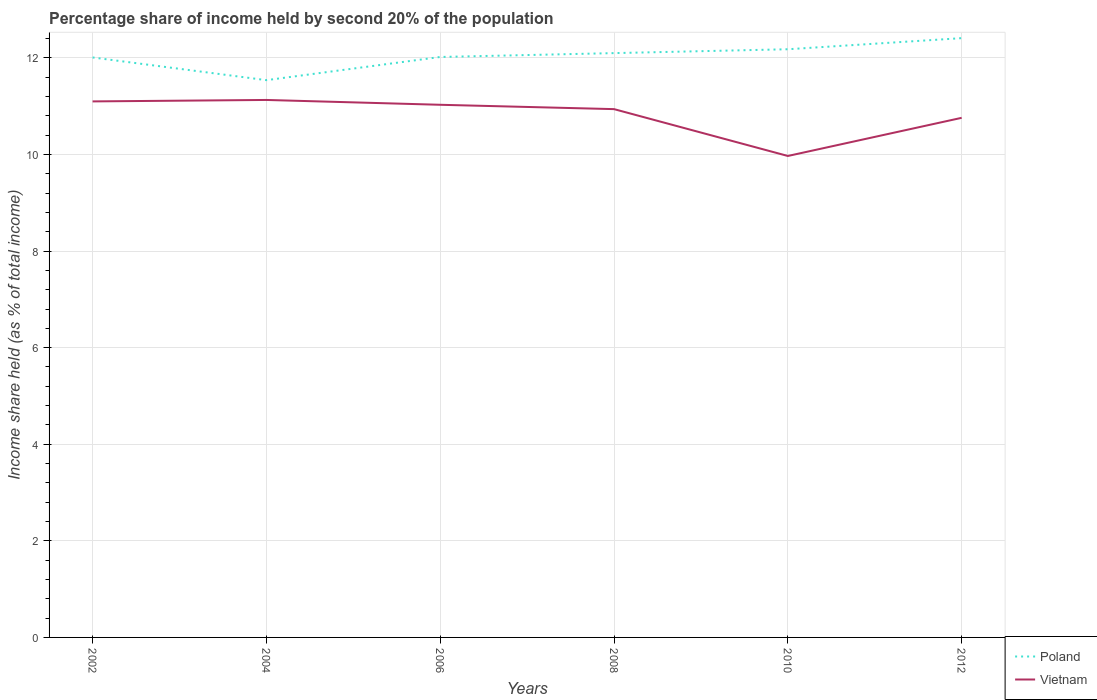How many different coloured lines are there?
Offer a very short reply. 2. Does the line corresponding to Poland intersect with the line corresponding to Vietnam?
Make the answer very short. No. Across all years, what is the maximum share of income held by second 20% of the population in Vietnam?
Your answer should be compact. 9.97. What is the total share of income held by second 20% of the population in Vietnam in the graph?
Your response must be concise. 0.07. What is the difference between the highest and the second highest share of income held by second 20% of the population in Poland?
Offer a very short reply. 0.87. How many lines are there?
Offer a terse response. 2. How many years are there in the graph?
Your response must be concise. 6. Are the values on the major ticks of Y-axis written in scientific E-notation?
Your answer should be very brief. No. Where does the legend appear in the graph?
Provide a succinct answer. Bottom right. How many legend labels are there?
Provide a succinct answer. 2. What is the title of the graph?
Ensure brevity in your answer.  Percentage share of income held by second 20% of the population. Does "Philippines" appear as one of the legend labels in the graph?
Your answer should be compact. No. What is the label or title of the X-axis?
Make the answer very short. Years. What is the label or title of the Y-axis?
Provide a succinct answer. Income share held (as % of total income). What is the Income share held (as % of total income) of Poland in 2002?
Offer a very short reply. 12.01. What is the Income share held (as % of total income) in Poland in 2004?
Your answer should be very brief. 11.54. What is the Income share held (as % of total income) of Vietnam in 2004?
Your response must be concise. 11.13. What is the Income share held (as % of total income) of Poland in 2006?
Offer a terse response. 12.02. What is the Income share held (as % of total income) in Vietnam in 2006?
Your answer should be very brief. 11.03. What is the Income share held (as % of total income) in Poland in 2008?
Offer a very short reply. 12.1. What is the Income share held (as % of total income) of Vietnam in 2008?
Make the answer very short. 10.94. What is the Income share held (as % of total income) in Poland in 2010?
Give a very brief answer. 12.18. What is the Income share held (as % of total income) of Vietnam in 2010?
Ensure brevity in your answer.  9.97. What is the Income share held (as % of total income) of Poland in 2012?
Offer a terse response. 12.41. What is the Income share held (as % of total income) in Vietnam in 2012?
Provide a short and direct response. 10.76. Across all years, what is the maximum Income share held (as % of total income) in Poland?
Offer a terse response. 12.41. Across all years, what is the maximum Income share held (as % of total income) of Vietnam?
Offer a very short reply. 11.13. Across all years, what is the minimum Income share held (as % of total income) of Poland?
Give a very brief answer. 11.54. Across all years, what is the minimum Income share held (as % of total income) in Vietnam?
Offer a very short reply. 9.97. What is the total Income share held (as % of total income) in Poland in the graph?
Offer a terse response. 72.26. What is the total Income share held (as % of total income) in Vietnam in the graph?
Provide a succinct answer. 64.93. What is the difference between the Income share held (as % of total income) in Poland in 2002 and that in 2004?
Offer a very short reply. 0.47. What is the difference between the Income share held (as % of total income) in Vietnam in 2002 and that in 2004?
Give a very brief answer. -0.03. What is the difference between the Income share held (as % of total income) of Poland in 2002 and that in 2006?
Keep it short and to the point. -0.01. What is the difference between the Income share held (as % of total income) in Vietnam in 2002 and that in 2006?
Provide a short and direct response. 0.07. What is the difference between the Income share held (as % of total income) in Poland in 2002 and that in 2008?
Give a very brief answer. -0.09. What is the difference between the Income share held (as % of total income) in Vietnam in 2002 and that in 2008?
Your answer should be very brief. 0.16. What is the difference between the Income share held (as % of total income) in Poland in 2002 and that in 2010?
Offer a very short reply. -0.17. What is the difference between the Income share held (as % of total income) in Vietnam in 2002 and that in 2010?
Give a very brief answer. 1.13. What is the difference between the Income share held (as % of total income) of Poland in 2002 and that in 2012?
Ensure brevity in your answer.  -0.4. What is the difference between the Income share held (as % of total income) in Vietnam in 2002 and that in 2012?
Your answer should be very brief. 0.34. What is the difference between the Income share held (as % of total income) in Poland in 2004 and that in 2006?
Your response must be concise. -0.48. What is the difference between the Income share held (as % of total income) of Poland in 2004 and that in 2008?
Keep it short and to the point. -0.56. What is the difference between the Income share held (as % of total income) of Vietnam in 2004 and that in 2008?
Provide a short and direct response. 0.19. What is the difference between the Income share held (as % of total income) of Poland in 2004 and that in 2010?
Offer a terse response. -0.64. What is the difference between the Income share held (as % of total income) in Vietnam in 2004 and that in 2010?
Offer a very short reply. 1.16. What is the difference between the Income share held (as % of total income) in Poland in 2004 and that in 2012?
Your answer should be very brief. -0.87. What is the difference between the Income share held (as % of total income) in Vietnam in 2004 and that in 2012?
Offer a very short reply. 0.37. What is the difference between the Income share held (as % of total income) in Poland in 2006 and that in 2008?
Give a very brief answer. -0.08. What is the difference between the Income share held (as % of total income) in Vietnam in 2006 and that in 2008?
Your response must be concise. 0.09. What is the difference between the Income share held (as % of total income) in Poland in 2006 and that in 2010?
Your response must be concise. -0.16. What is the difference between the Income share held (as % of total income) of Vietnam in 2006 and that in 2010?
Offer a terse response. 1.06. What is the difference between the Income share held (as % of total income) in Poland in 2006 and that in 2012?
Provide a succinct answer. -0.39. What is the difference between the Income share held (as % of total income) of Vietnam in 2006 and that in 2012?
Keep it short and to the point. 0.27. What is the difference between the Income share held (as % of total income) of Poland in 2008 and that in 2010?
Your response must be concise. -0.08. What is the difference between the Income share held (as % of total income) in Poland in 2008 and that in 2012?
Your response must be concise. -0.31. What is the difference between the Income share held (as % of total income) of Vietnam in 2008 and that in 2012?
Your answer should be very brief. 0.18. What is the difference between the Income share held (as % of total income) of Poland in 2010 and that in 2012?
Offer a terse response. -0.23. What is the difference between the Income share held (as % of total income) in Vietnam in 2010 and that in 2012?
Ensure brevity in your answer.  -0.79. What is the difference between the Income share held (as % of total income) in Poland in 2002 and the Income share held (as % of total income) in Vietnam in 2004?
Make the answer very short. 0.88. What is the difference between the Income share held (as % of total income) of Poland in 2002 and the Income share held (as % of total income) of Vietnam in 2006?
Your response must be concise. 0.98. What is the difference between the Income share held (as % of total income) of Poland in 2002 and the Income share held (as % of total income) of Vietnam in 2008?
Provide a succinct answer. 1.07. What is the difference between the Income share held (as % of total income) in Poland in 2002 and the Income share held (as % of total income) in Vietnam in 2010?
Give a very brief answer. 2.04. What is the difference between the Income share held (as % of total income) in Poland in 2004 and the Income share held (as % of total income) in Vietnam in 2006?
Give a very brief answer. 0.51. What is the difference between the Income share held (as % of total income) of Poland in 2004 and the Income share held (as % of total income) of Vietnam in 2008?
Keep it short and to the point. 0.6. What is the difference between the Income share held (as % of total income) in Poland in 2004 and the Income share held (as % of total income) in Vietnam in 2010?
Ensure brevity in your answer.  1.57. What is the difference between the Income share held (as % of total income) in Poland in 2004 and the Income share held (as % of total income) in Vietnam in 2012?
Make the answer very short. 0.78. What is the difference between the Income share held (as % of total income) in Poland in 2006 and the Income share held (as % of total income) in Vietnam in 2010?
Offer a terse response. 2.05. What is the difference between the Income share held (as % of total income) in Poland in 2006 and the Income share held (as % of total income) in Vietnam in 2012?
Ensure brevity in your answer.  1.26. What is the difference between the Income share held (as % of total income) in Poland in 2008 and the Income share held (as % of total income) in Vietnam in 2010?
Offer a very short reply. 2.13. What is the difference between the Income share held (as % of total income) in Poland in 2008 and the Income share held (as % of total income) in Vietnam in 2012?
Provide a short and direct response. 1.34. What is the difference between the Income share held (as % of total income) in Poland in 2010 and the Income share held (as % of total income) in Vietnam in 2012?
Provide a succinct answer. 1.42. What is the average Income share held (as % of total income) in Poland per year?
Keep it short and to the point. 12.04. What is the average Income share held (as % of total income) of Vietnam per year?
Your response must be concise. 10.82. In the year 2002, what is the difference between the Income share held (as % of total income) in Poland and Income share held (as % of total income) in Vietnam?
Ensure brevity in your answer.  0.91. In the year 2004, what is the difference between the Income share held (as % of total income) in Poland and Income share held (as % of total income) in Vietnam?
Your answer should be compact. 0.41. In the year 2006, what is the difference between the Income share held (as % of total income) of Poland and Income share held (as % of total income) of Vietnam?
Your response must be concise. 0.99. In the year 2008, what is the difference between the Income share held (as % of total income) in Poland and Income share held (as % of total income) in Vietnam?
Give a very brief answer. 1.16. In the year 2010, what is the difference between the Income share held (as % of total income) in Poland and Income share held (as % of total income) in Vietnam?
Provide a succinct answer. 2.21. In the year 2012, what is the difference between the Income share held (as % of total income) of Poland and Income share held (as % of total income) of Vietnam?
Offer a very short reply. 1.65. What is the ratio of the Income share held (as % of total income) of Poland in 2002 to that in 2004?
Make the answer very short. 1.04. What is the ratio of the Income share held (as % of total income) in Vietnam in 2002 to that in 2004?
Offer a terse response. 1. What is the ratio of the Income share held (as % of total income) in Poland in 2002 to that in 2006?
Offer a very short reply. 1. What is the ratio of the Income share held (as % of total income) of Vietnam in 2002 to that in 2008?
Ensure brevity in your answer.  1.01. What is the ratio of the Income share held (as % of total income) in Vietnam in 2002 to that in 2010?
Provide a short and direct response. 1.11. What is the ratio of the Income share held (as % of total income) in Poland in 2002 to that in 2012?
Offer a terse response. 0.97. What is the ratio of the Income share held (as % of total income) in Vietnam in 2002 to that in 2012?
Your answer should be compact. 1.03. What is the ratio of the Income share held (as % of total income) of Poland in 2004 to that in 2006?
Keep it short and to the point. 0.96. What is the ratio of the Income share held (as % of total income) in Vietnam in 2004 to that in 2006?
Your answer should be compact. 1.01. What is the ratio of the Income share held (as % of total income) of Poland in 2004 to that in 2008?
Your response must be concise. 0.95. What is the ratio of the Income share held (as % of total income) in Vietnam in 2004 to that in 2008?
Keep it short and to the point. 1.02. What is the ratio of the Income share held (as % of total income) in Poland in 2004 to that in 2010?
Your answer should be very brief. 0.95. What is the ratio of the Income share held (as % of total income) of Vietnam in 2004 to that in 2010?
Offer a very short reply. 1.12. What is the ratio of the Income share held (as % of total income) in Poland in 2004 to that in 2012?
Offer a very short reply. 0.93. What is the ratio of the Income share held (as % of total income) of Vietnam in 2004 to that in 2012?
Your answer should be very brief. 1.03. What is the ratio of the Income share held (as % of total income) of Poland in 2006 to that in 2008?
Provide a short and direct response. 0.99. What is the ratio of the Income share held (as % of total income) of Vietnam in 2006 to that in 2008?
Keep it short and to the point. 1.01. What is the ratio of the Income share held (as % of total income) in Poland in 2006 to that in 2010?
Your answer should be compact. 0.99. What is the ratio of the Income share held (as % of total income) of Vietnam in 2006 to that in 2010?
Keep it short and to the point. 1.11. What is the ratio of the Income share held (as % of total income) in Poland in 2006 to that in 2012?
Provide a short and direct response. 0.97. What is the ratio of the Income share held (as % of total income) in Vietnam in 2006 to that in 2012?
Offer a terse response. 1.03. What is the ratio of the Income share held (as % of total income) in Vietnam in 2008 to that in 2010?
Keep it short and to the point. 1.1. What is the ratio of the Income share held (as % of total income) in Poland in 2008 to that in 2012?
Ensure brevity in your answer.  0.97. What is the ratio of the Income share held (as % of total income) in Vietnam in 2008 to that in 2012?
Make the answer very short. 1.02. What is the ratio of the Income share held (as % of total income) in Poland in 2010 to that in 2012?
Offer a terse response. 0.98. What is the ratio of the Income share held (as % of total income) of Vietnam in 2010 to that in 2012?
Provide a succinct answer. 0.93. What is the difference between the highest and the second highest Income share held (as % of total income) of Poland?
Keep it short and to the point. 0.23. What is the difference between the highest and the second highest Income share held (as % of total income) in Vietnam?
Your response must be concise. 0.03. What is the difference between the highest and the lowest Income share held (as % of total income) in Poland?
Provide a short and direct response. 0.87. What is the difference between the highest and the lowest Income share held (as % of total income) of Vietnam?
Ensure brevity in your answer.  1.16. 